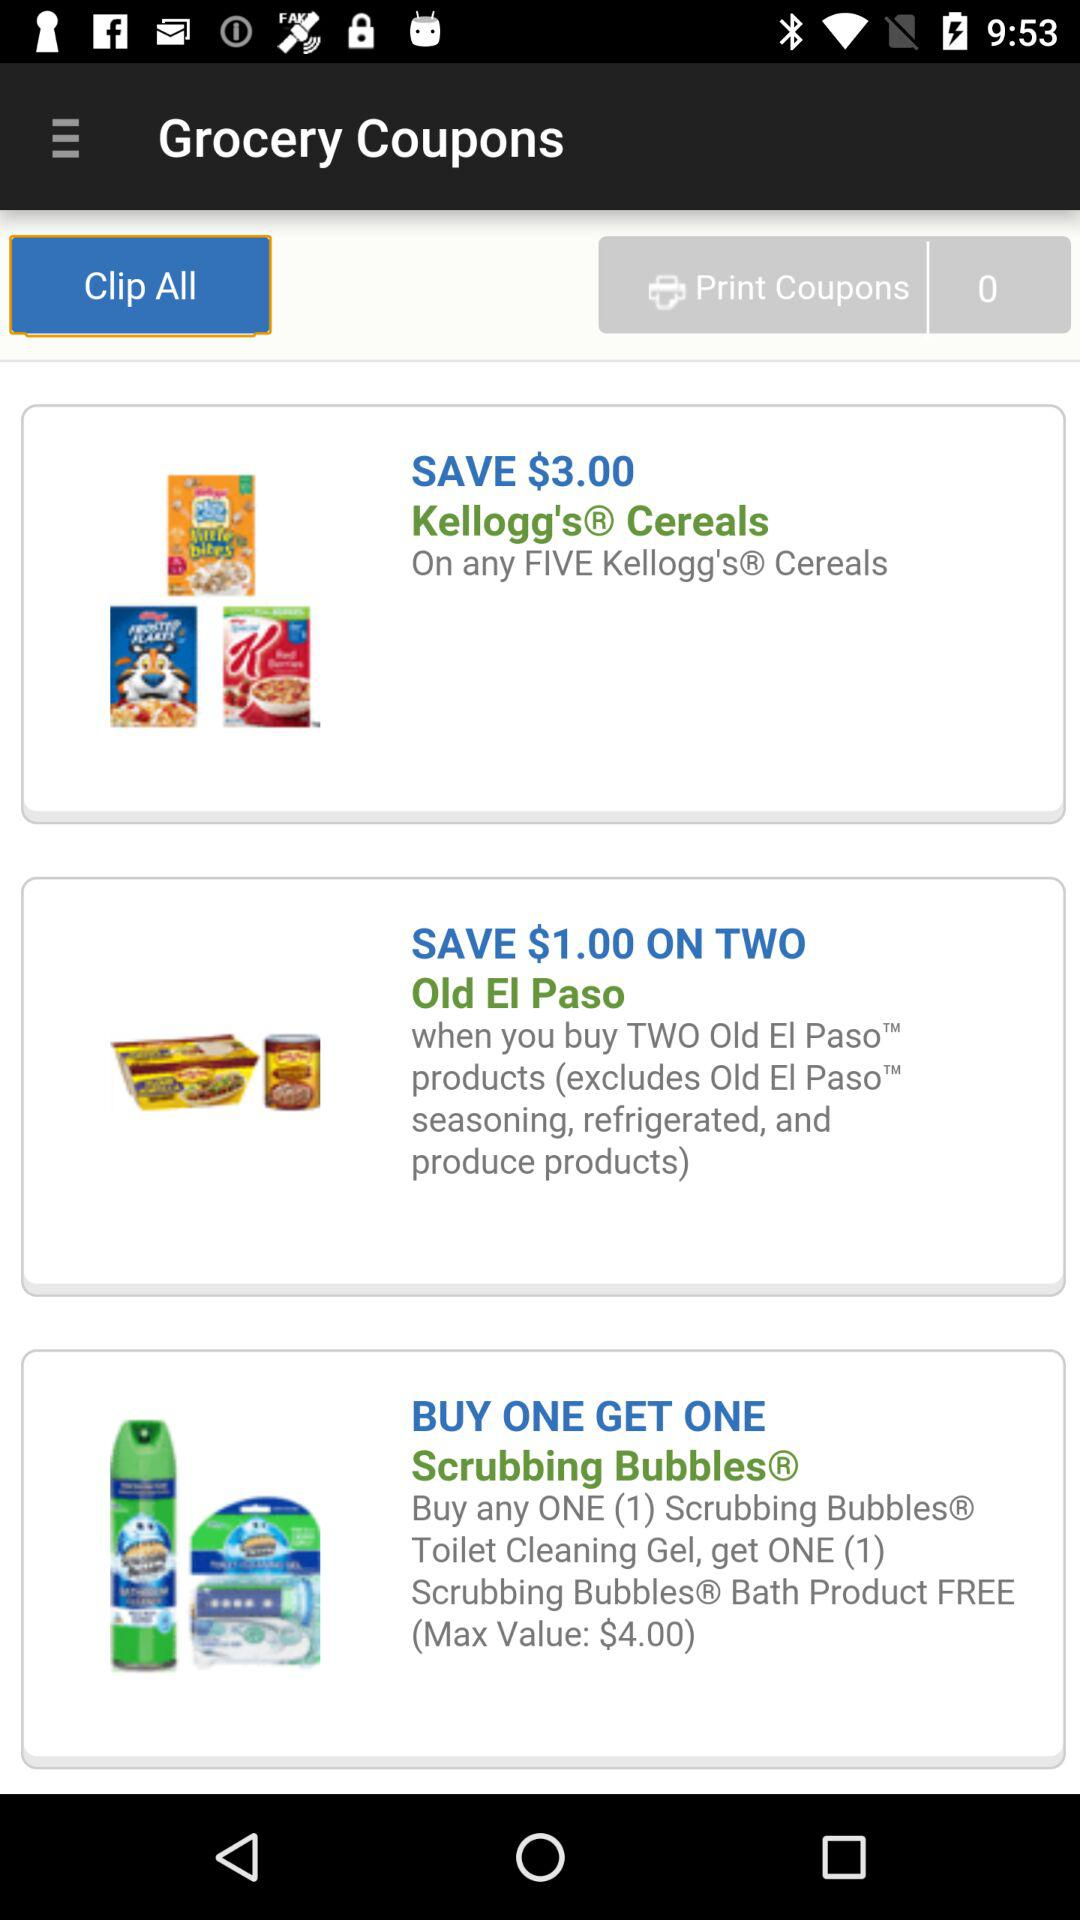How many more Kellogg's products do I need to buy to get $3.00 off?
Answer the question using a single word or phrase. 5 